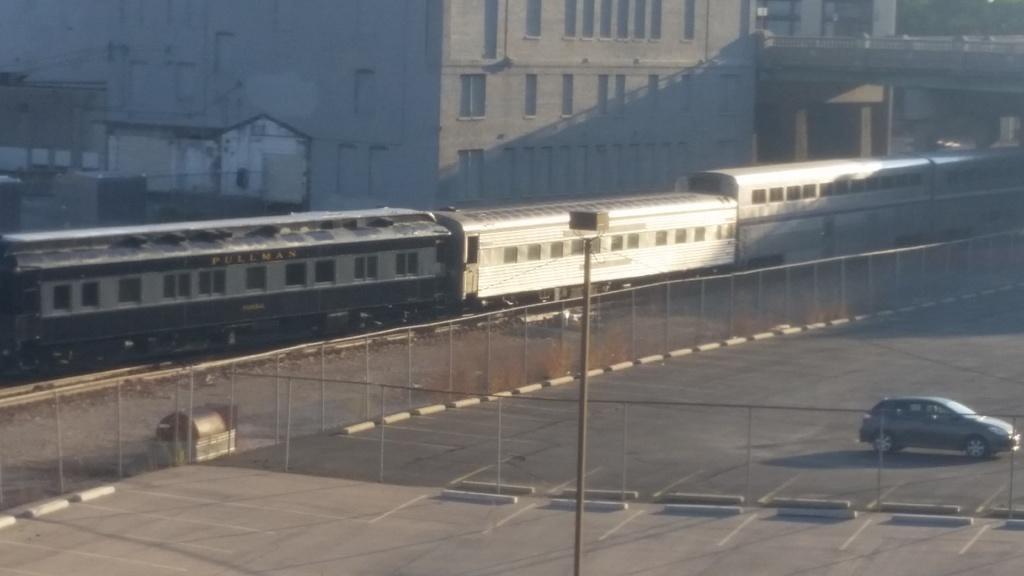Please provide a concise description of this image. In this picture, on bottom right hand corner there is a car and in the middle there is a pole and there is a train from left to right. 